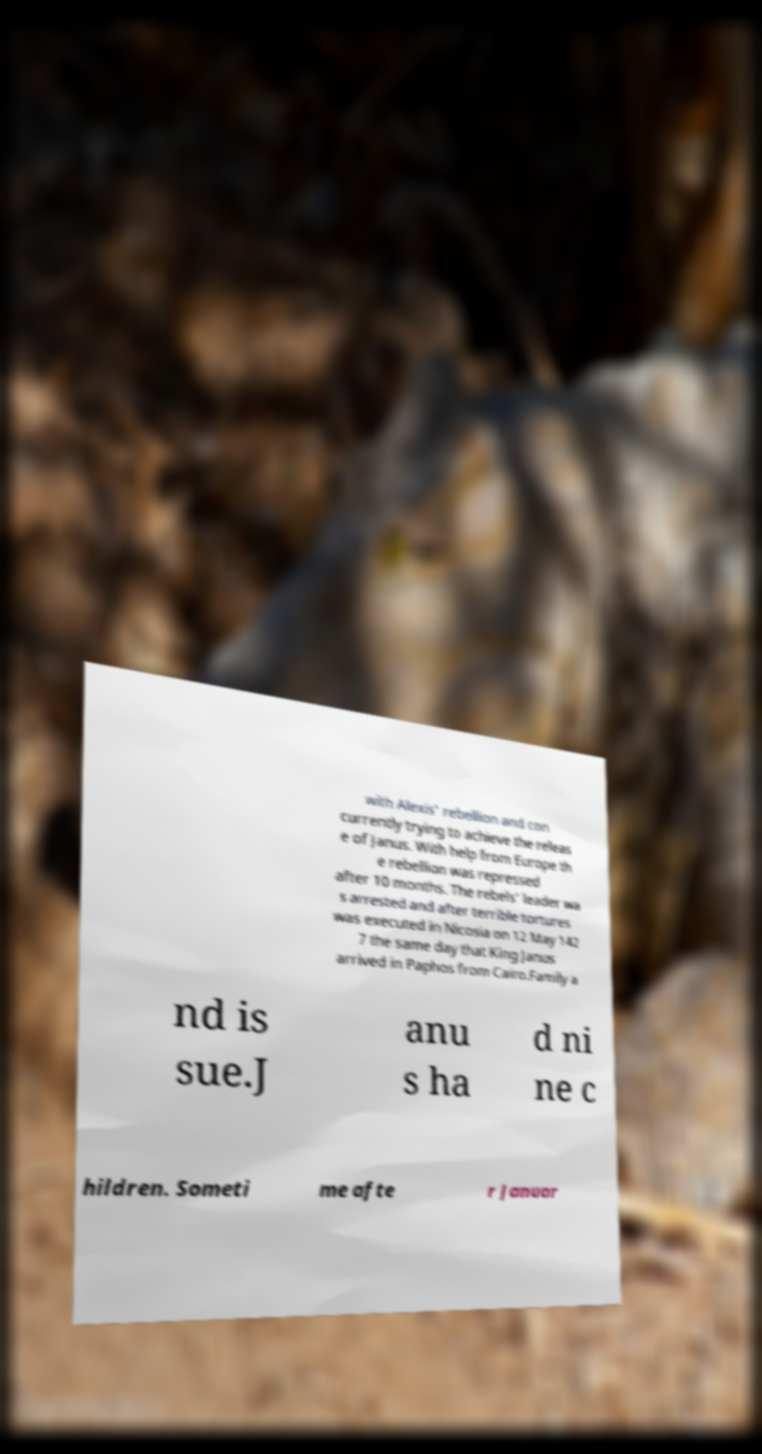Can you read and provide the text displayed in the image?This photo seems to have some interesting text. Can you extract and type it out for me? with Alexis' rebellion and con currently trying to achieve the releas e of Janus. With help from Europe th e rebellion was repressed after 10 months. The rebels' leader wa s arrested and after terrible tortures was executed in Nicosia on 12 May 142 7 the same day that King Janus arrived in Paphos from Cairo.Family a nd is sue.J anu s ha d ni ne c hildren. Someti me afte r Januar 